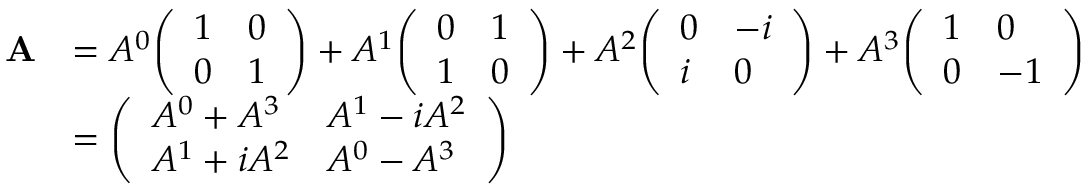Convert formula to latex. <formula><loc_0><loc_0><loc_500><loc_500>{ \begin{array} { r l } { A } & { = A ^ { 0 } { \left ( \begin{array} { l l } { 1 } & { 0 } \\ { 0 } & { 1 } \end{array} \right ) } + A ^ { 1 } { \left ( \begin{array} { l l } { 0 } & { 1 } \\ { 1 } & { 0 } \end{array} \right ) } + A ^ { 2 } { \left ( \begin{array} { l l } { 0 } & { - i } \\ { i } & { 0 } \end{array} \right ) } + A ^ { 3 } { \left ( \begin{array} { l l } { 1 } & { 0 } \\ { 0 } & { - 1 } \end{array} \right ) } } \\ & { = { \left ( \begin{array} { l l } { A ^ { 0 } + A ^ { 3 } } & { A ^ { 1 } - i A ^ { 2 } } \\ { A ^ { 1 } + i A ^ { 2 } } & { A ^ { 0 } - A ^ { 3 } } \end{array} \right ) } } \end{array} }</formula> 